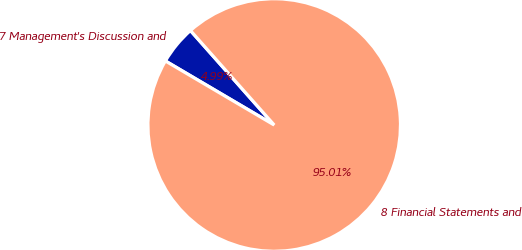Convert chart to OTSL. <chart><loc_0><loc_0><loc_500><loc_500><pie_chart><fcel>7 Management's Discussion and<fcel>8 Financial Statements and<nl><fcel>4.99%<fcel>95.01%<nl></chart> 